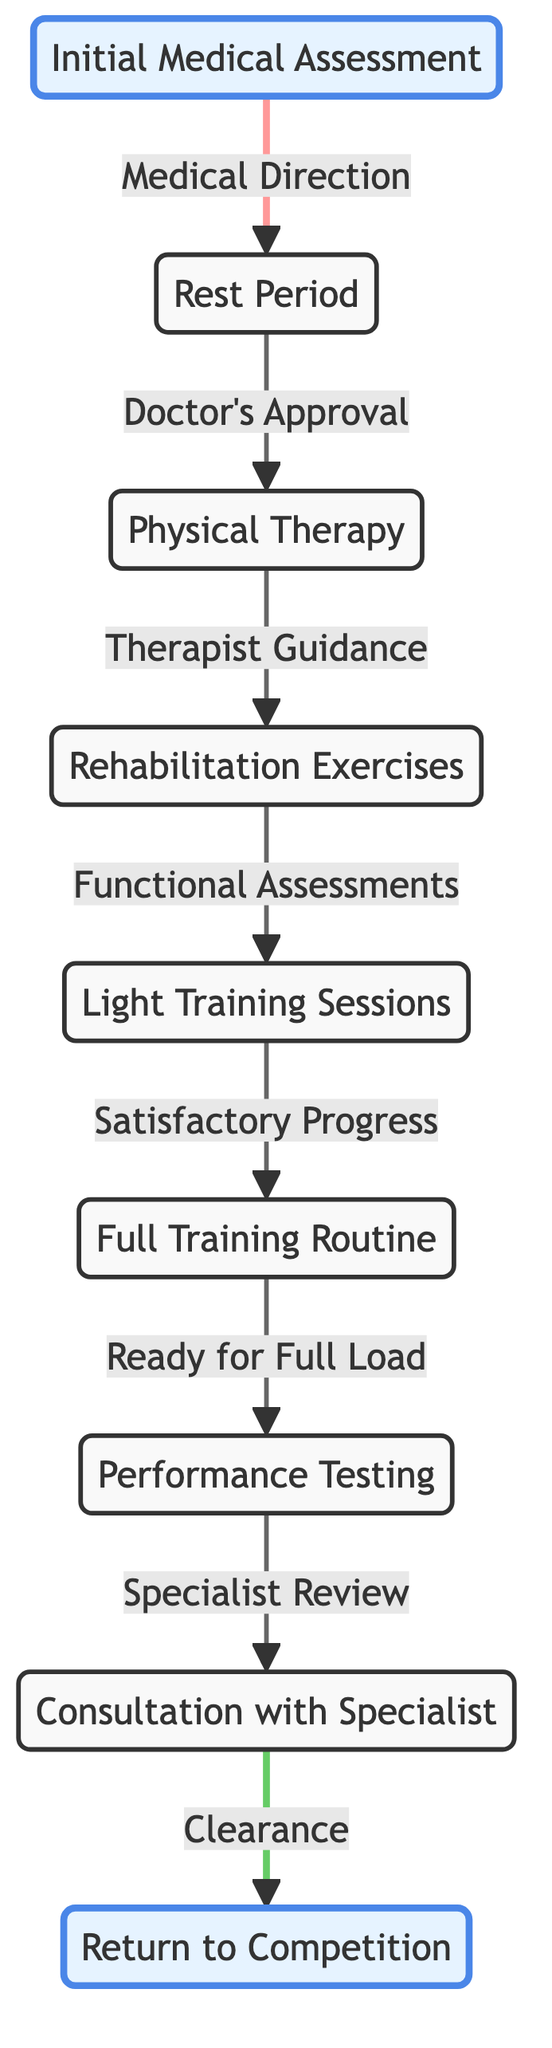What is the first step in the recovery protocol? The first step in the recovery protocol is represented by the node labeled "Initial Medical Assessment." This is where the recovery process begins.
Answer: Initial Medical Assessment How many nodes are present in this directed graph? By counting each unique step in the graph, we have the following nodes: Initial Medical Assessment, Rest Period, Physical Therapy, Rehabilitation Exercises, Light Training Sessions, Full Training Routine, Performance Testing, Consultation with Specialist, and Return to Competition. There are a total of 9 nodes.
Answer: 9 What is the label of the node that comes after the "Rest Period"? Following the "Rest Period," the next step is linked to it through "Doctor's Approval," leading to the node labeled "Physical Therapy." This establishes the transition between these two steps in the protocol.
Answer: Physical Therapy What type of review happens before the "Return to Competition"? The last node before the "Return to Competition" is associated with a "Specialist Review." This informs the athlete's readiness to return to competition following a performance test.
Answer: Specialist Review What is the relationship between "Rehabilitation Exercises" and "Light Training Sessions"? The connection from "Rehabilitation Exercises" to "Light Training Sessions" is characterized by the "Functional Assessments," indicating a progression based on the athlete's recovery status.
Answer: Functional Assessments Which step follows "Full Training Routine"? After successfully completing the "Full Training Routine," the subsequent step is "Performance Testing." This transition indicates that the athlete is being evaluated for their readiness following full training.
Answer: Performance Testing What is the final step in the recovery process? The concluding step in this directed graph is represented by the node labeled "Return to Competition," marking the successful completion of the recovery protocol.
Answer: Return to Competition How many edges are in this directed graph? We analyze the directed connections between the nodes, finding that there are 8 distinct edges that define the flow of the recovery steps.
Answer: 8 What is the significance of "Consultation with Specialist" in the diagram? The significance of "Consultation with Specialist" is pivotal as it follows the "Performance Test" and leads to "Return to Competition," serving as a necessary final check for clearance before the athlete can compete again.
Answer: Clearance 